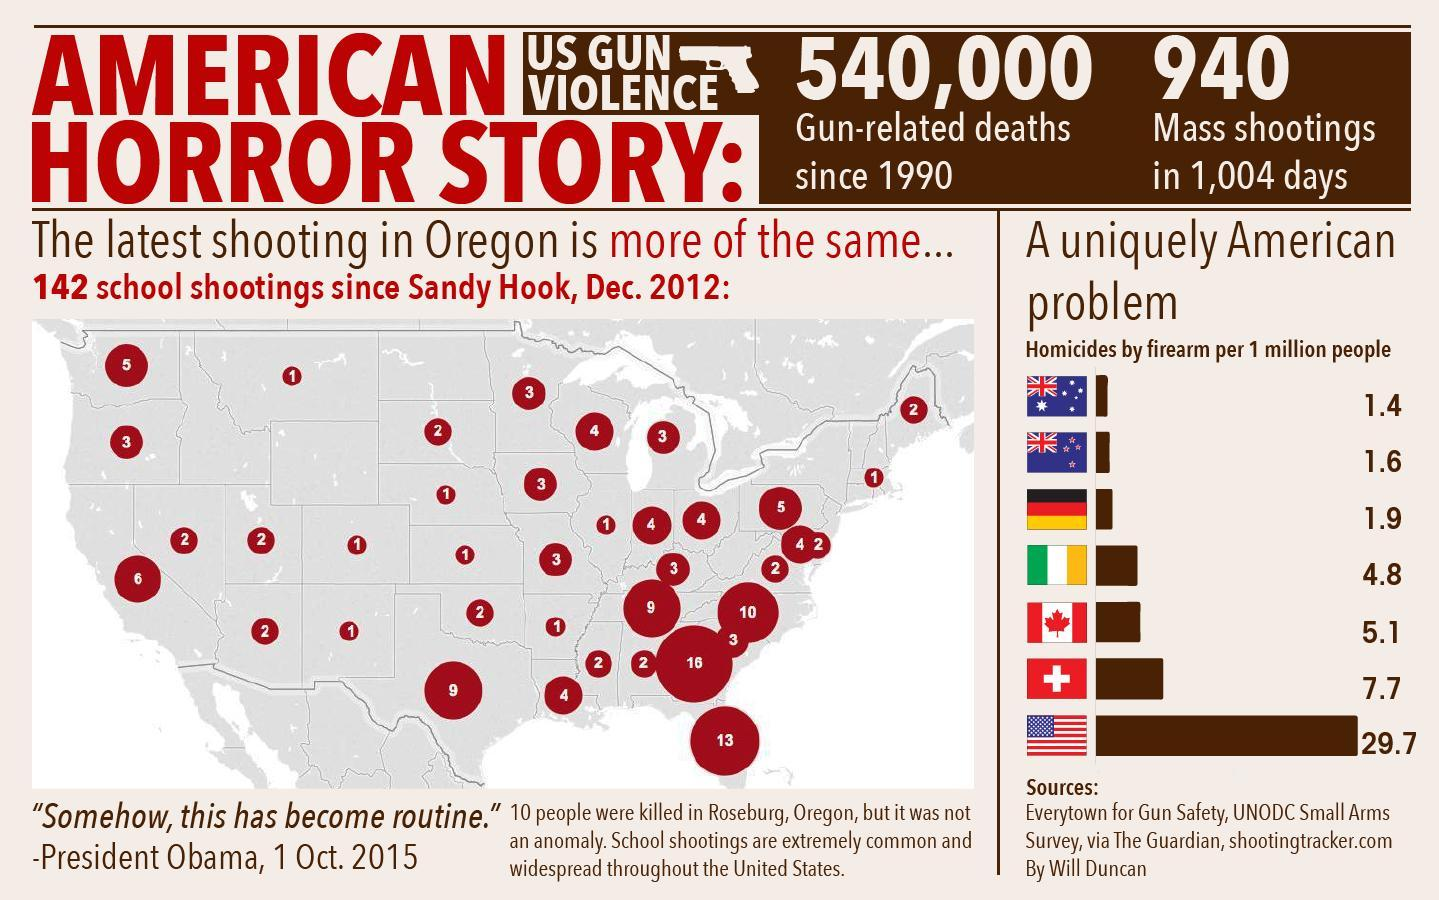In how many days, 940 mass shootings were reported in U.S?
Answer the question with a short phrase. in 1,004 days What is the no of gun-related deaths reported in U.S since 1990? 540,000 